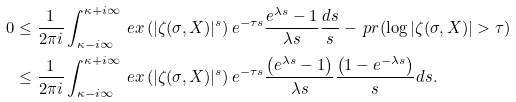<formula> <loc_0><loc_0><loc_500><loc_500>0 & \leq \frac { 1 } { 2 \pi i } \int _ { \kappa - i \infty } ^ { \kappa + i \infty } \ e x \left ( | \zeta ( \sigma , X ) | ^ { s } \right ) e ^ { - \tau s } \frac { e ^ { \lambda s } - 1 } { \lambda s } \frac { d s } { s } - \ p r ( \log | \zeta ( \sigma , X ) | > \tau ) \\ & \leq \frac { 1 } { 2 \pi i } \int _ { \kappa - i \infty } ^ { \kappa + i \infty } \ e x \left ( | \zeta ( \sigma , X ) | ^ { s } \right ) e ^ { - \tau s } \frac { \left ( e ^ { \lambda s } - 1 \right ) } { \lambda s } \frac { \left ( 1 - e ^ { - \lambda s } \right ) } { s } d s .</formula> 